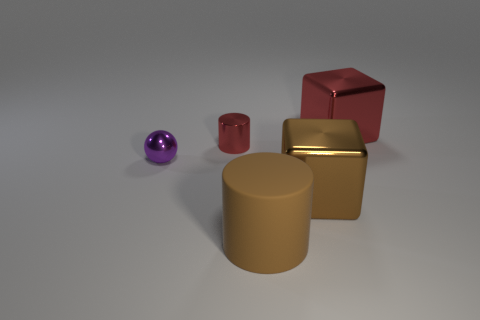How many objects are both to the left of the brown metal cube and in front of the tiny ball?
Provide a short and direct response. 1. What number of yellow objects are large metallic cubes or tiny things?
Provide a short and direct response. 0. What number of metallic objects are either big red blocks or red cylinders?
Your answer should be compact. 2. Are any small gray matte cylinders visible?
Provide a short and direct response. No. Do the tiny purple object and the large red metal thing have the same shape?
Offer a very short reply. No. How many tiny red shiny objects are left of the small metallic object that is on the right side of the metallic thing that is on the left side of the shiny cylinder?
Your answer should be very brief. 0. What is the object that is both behind the purple metallic object and on the right side of the small red cylinder made of?
Provide a short and direct response. Metal. The metal object that is both in front of the big red cube and right of the red metallic cylinder is what color?
Make the answer very short. Brown. Is there any other thing of the same color as the rubber thing?
Your response must be concise. Yes. The large object that is behind the metallic block left of the big shiny block that is behind the big brown block is what shape?
Give a very brief answer. Cube. 